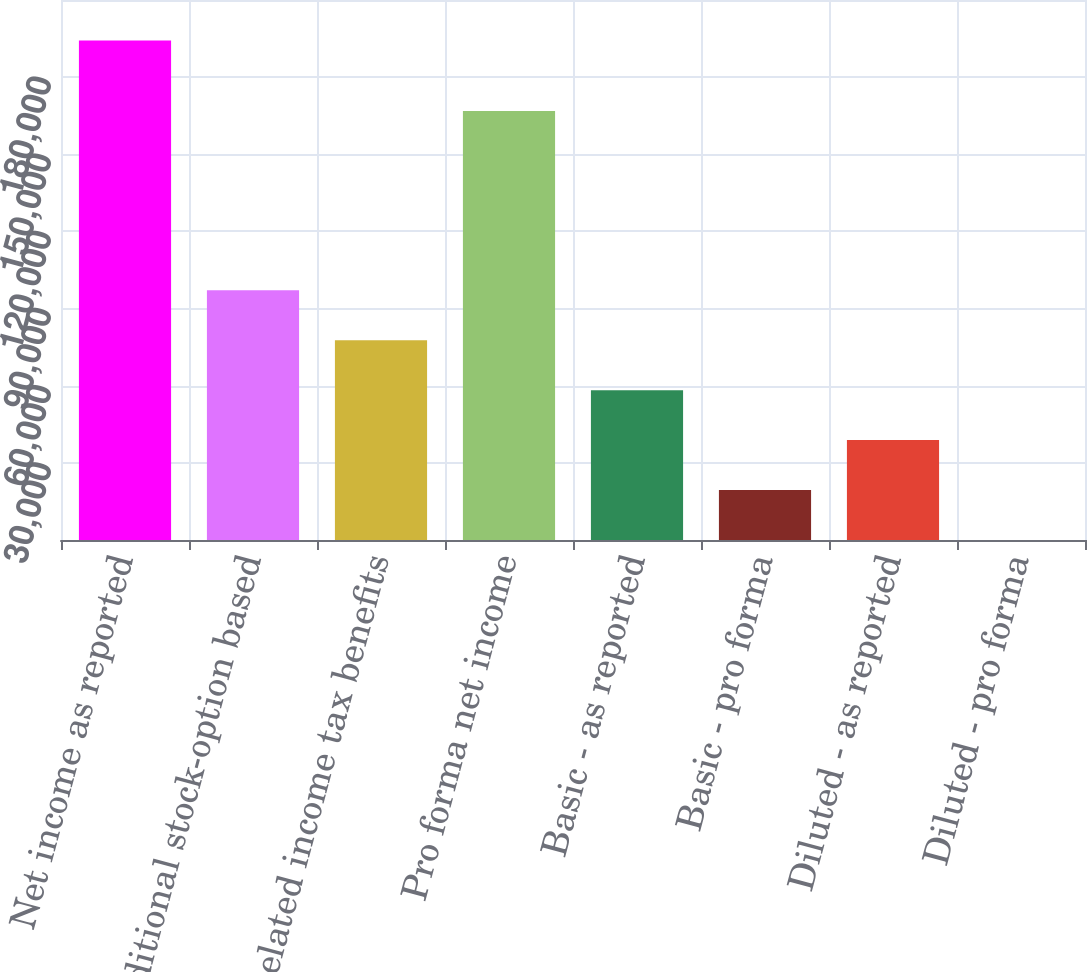Convert chart. <chart><loc_0><loc_0><loc_500><loc_500><bar_chart><fcel>Net income as reported<fcel>Additional stock-option based<fcel>Related income tax benefits<fcel>Pro forma net income<fcel>Basic - as reported<fcel>Basic - pro forma<fcel>Diluted - as reported<fcel>Diluted - pro forma<nl><fcel>194254<fcel>97127.7<fcel>77702.4<fcel>166870<fcel>58277.1<fcel>19426.6<fcel>38851.8<fcel>1.31<nl></chart> 